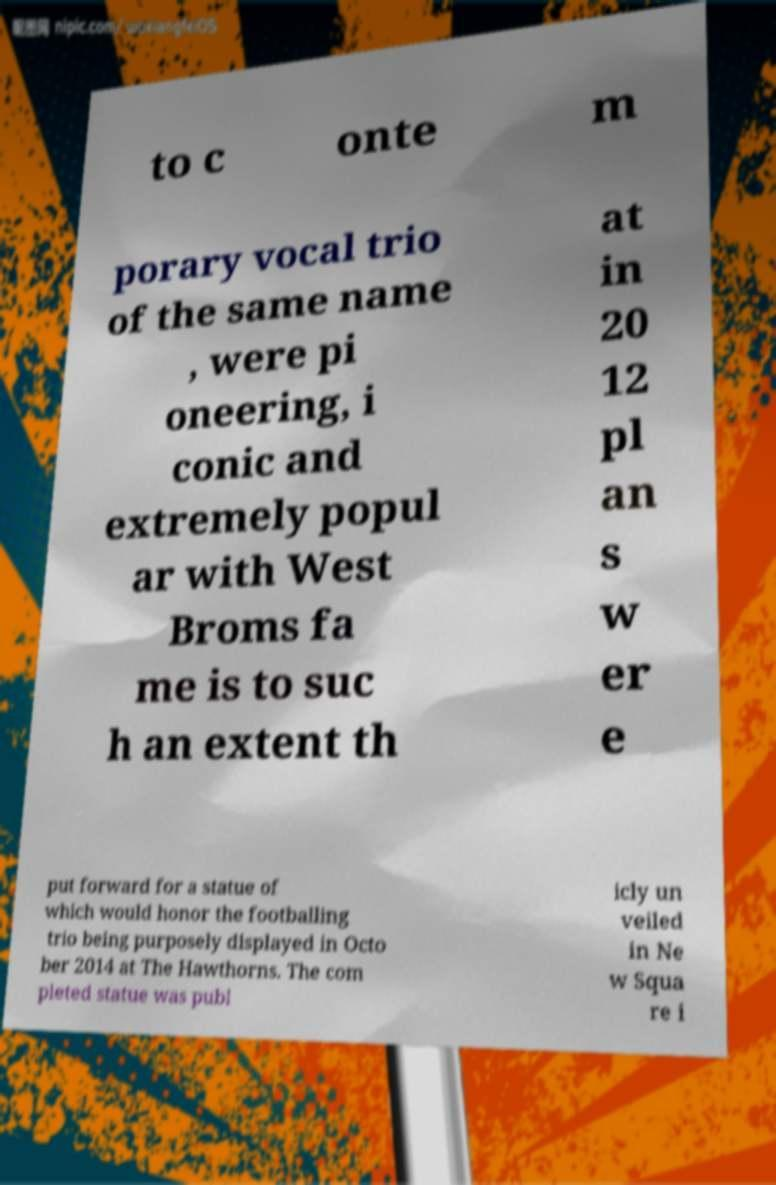For documentation purposes, I need the text within this image transcribed. Could you provide that? to c onte m porary vocal trio of the same name , were pi oneering, i conic and extremely popul ar with West Broms fa me is to suc h an extent th at in 20 12 pl an s w er e put forward for a statue of which would honor the footballing trio being purposely displayed in Octo ber 2014 at The Hawthorns. The com pleted statue was publ icly un veiled in Ne w Squa re i 